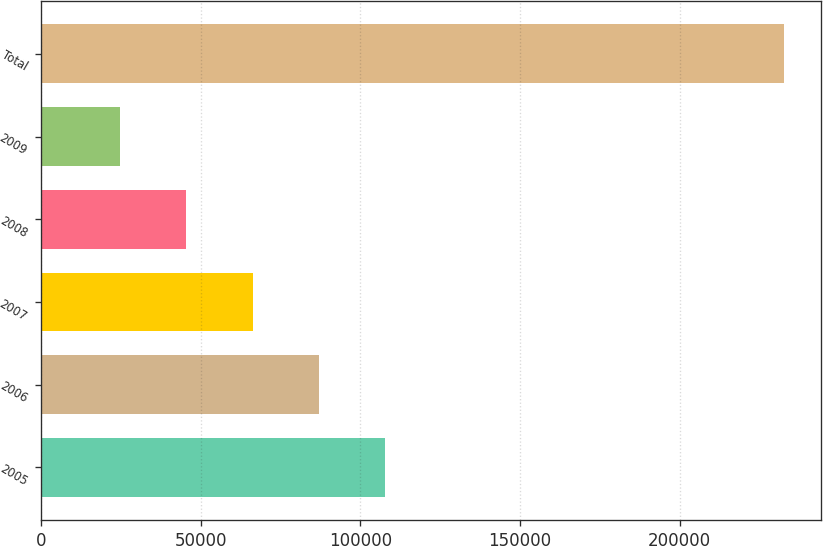Convert chart. <chart><loc_0><loc_0><loc_500><loc_500><bar_chart><fcel>2005<fcel>2006<fcel>2007<fcel>2008<fcel>2009<fcel>Total<nl><fcel>107873<fcel>87076.4<fcel>66279.6<fcel>45482.8<fcel>24686<fcel>232654<nl></chart> 